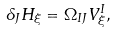Convert formula to latex. <formula><loc_0><loc_0><loc_500><loc_500>\delta _ { J } H _ { \xi } = \Omega _ { I J } V ^ { I } _ { \xi } ,</formula> 